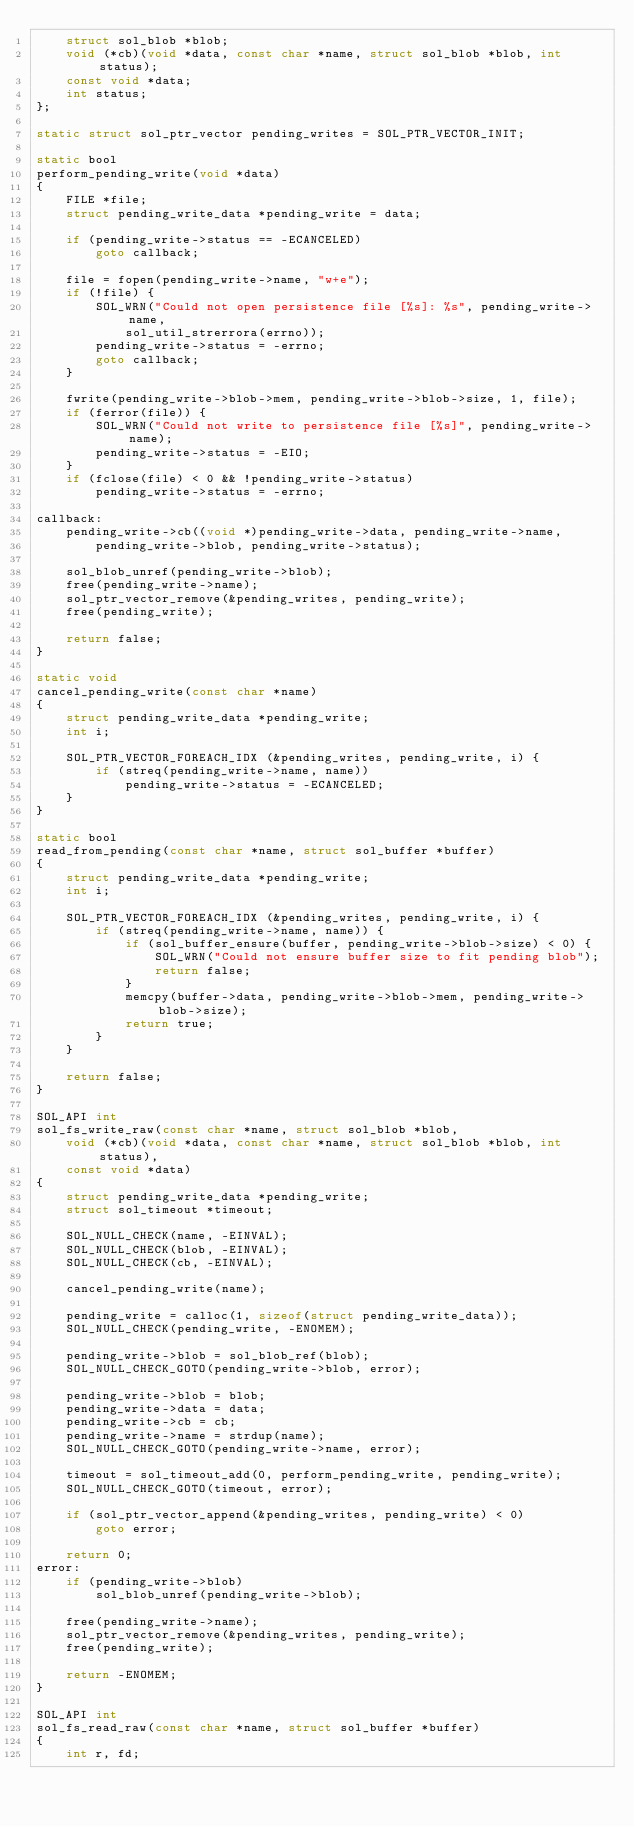<code> <loc_0><loc_0><loc_500><loc_500><_C_>    struct sol_blob *blob;
    void (*cb)(void *data, const char *name, struct sol_blob *blob, int status);
    const void *data;
    int status;
};

static struct sol_ptr_vector pending_writes = SOL_PTR_VECTOR_INIT;

static bool
perform_pending_write(void *data)
{
    FILE *file;
    struct pending_write_data *pending_write = data;

    if (pending_write->status == -ECANCELED)
        goto callback;

    file = fopen(pending_write->name, "w+e");
    if (!file) {
        SOL_WRN("Could not open persistence file [%s]: %s", pending_write->name,
            sol_util_strerrora(errno));
        pending_write->status = -errno;
        goto callback;
    }

    fwrite(pending_write->blob->mem, pending_write->blob->size, 1, file);
    if (ferror(file)) {
        SOL_WRN("Could not write to persistence file [%s]", pending_write->name);
        pending_write->status = -EIO;
    }
    if (fclose(file) < 0 && !pending_write->status)
        pending_write->status = -errno;

callback:
    pending_write->cb((void *)pending_write->data, pending_write->name,
        pending_write->blob, pending_write->status);

    sol_blob_unref(pending_write->blob);
    free(pending_write->name);
    sol_ptr_vector_remove(&pending_writes, pending_write);
    free(pending_write);

    return false;
}

static void
cancel_pending_write(const char *name)
{
    struct pending_write_data *pending_write;
    int i;

    SOL_PTR_VECTOR_FOREACH_IDX (&pending_writes, pending_write, i) {
        if (streq(pending_write->name, name))
            pending_write->status = -ECANCELED;
    }
}

static bool
read_from_pending(const char *name, struct sol_buffer *buffer)
{
    struct pending_write_data *pending_write;
    int i;

    SOL_PTR_VECTOR_FOREACH_IDX (&pending_writes, pending_write, i) {
        if (streq(pending_write->name, name)) {
            if (sol_buffer_ensure(buffer, pending_write->blob->size) < 0) {
                SOL_WRN("Could not ensure buffer size to fit pending blob");
                return false;
            }
            memcpy(buffer->data, pending_write->blob->mem, pending_write->blob->size);
            return true;
        }
    }

    return false;
}

SOL_API int
sol_fs_write_raw(const char *name, struct sol_blob *blob,
    void (*cb)(void *data, const char *name, struct sol_blob *blob, int status),
    const void *data)
{
    struct pending_write_data *pending_write;
    struct sol_timeout *timeout;

    SOL_NULL_CHECK(name, -EINVAL);
    SOL_NULL_CHECK(blob, -EINVAL);
    SOL_NULL_CHECK(cb, -EINVAL);

    cancel_pending_write(name);

    pending_write = calloc(1, sizeof(struct pending_write_data));
    SOL_NULL_CHECK(pending_write, -ENOMEM);

    pending_write->blob = sol_blob_ref(blob);
    SOL_NULL_CHECK_GOTO(pending_write->blob, error);

    pending_write->blob = blob;
    pending_write->data = data;
    pending_write->cb = cb;
    pending_write->name = strdup(name);
    SOL_NULL_CHECK_GOTO(pending_write->name, error);

    timeout = sol_timeout_add(0, perform_pending_write, pending_write);
    SOL_NULL_CHECK_GOTO(timeout, error);

    if (sol_ptr_vector_append(&pending_writes, pending_write) < 0)
        goto error;

    return 0;
error:
    if (pending_write->blob)
        sol_blob_unref(pending_write->blob);

    free(pending_write->name);
    sol_ptr_vector_remove(&pending_writes, pending_write);
    free(pending_write);

    return -ENOMEM;
}

SOL_API int
sol_fs_read_raw(const char *name, struct sol_buffer *buffer)
{
    int r, fd;
</code> 